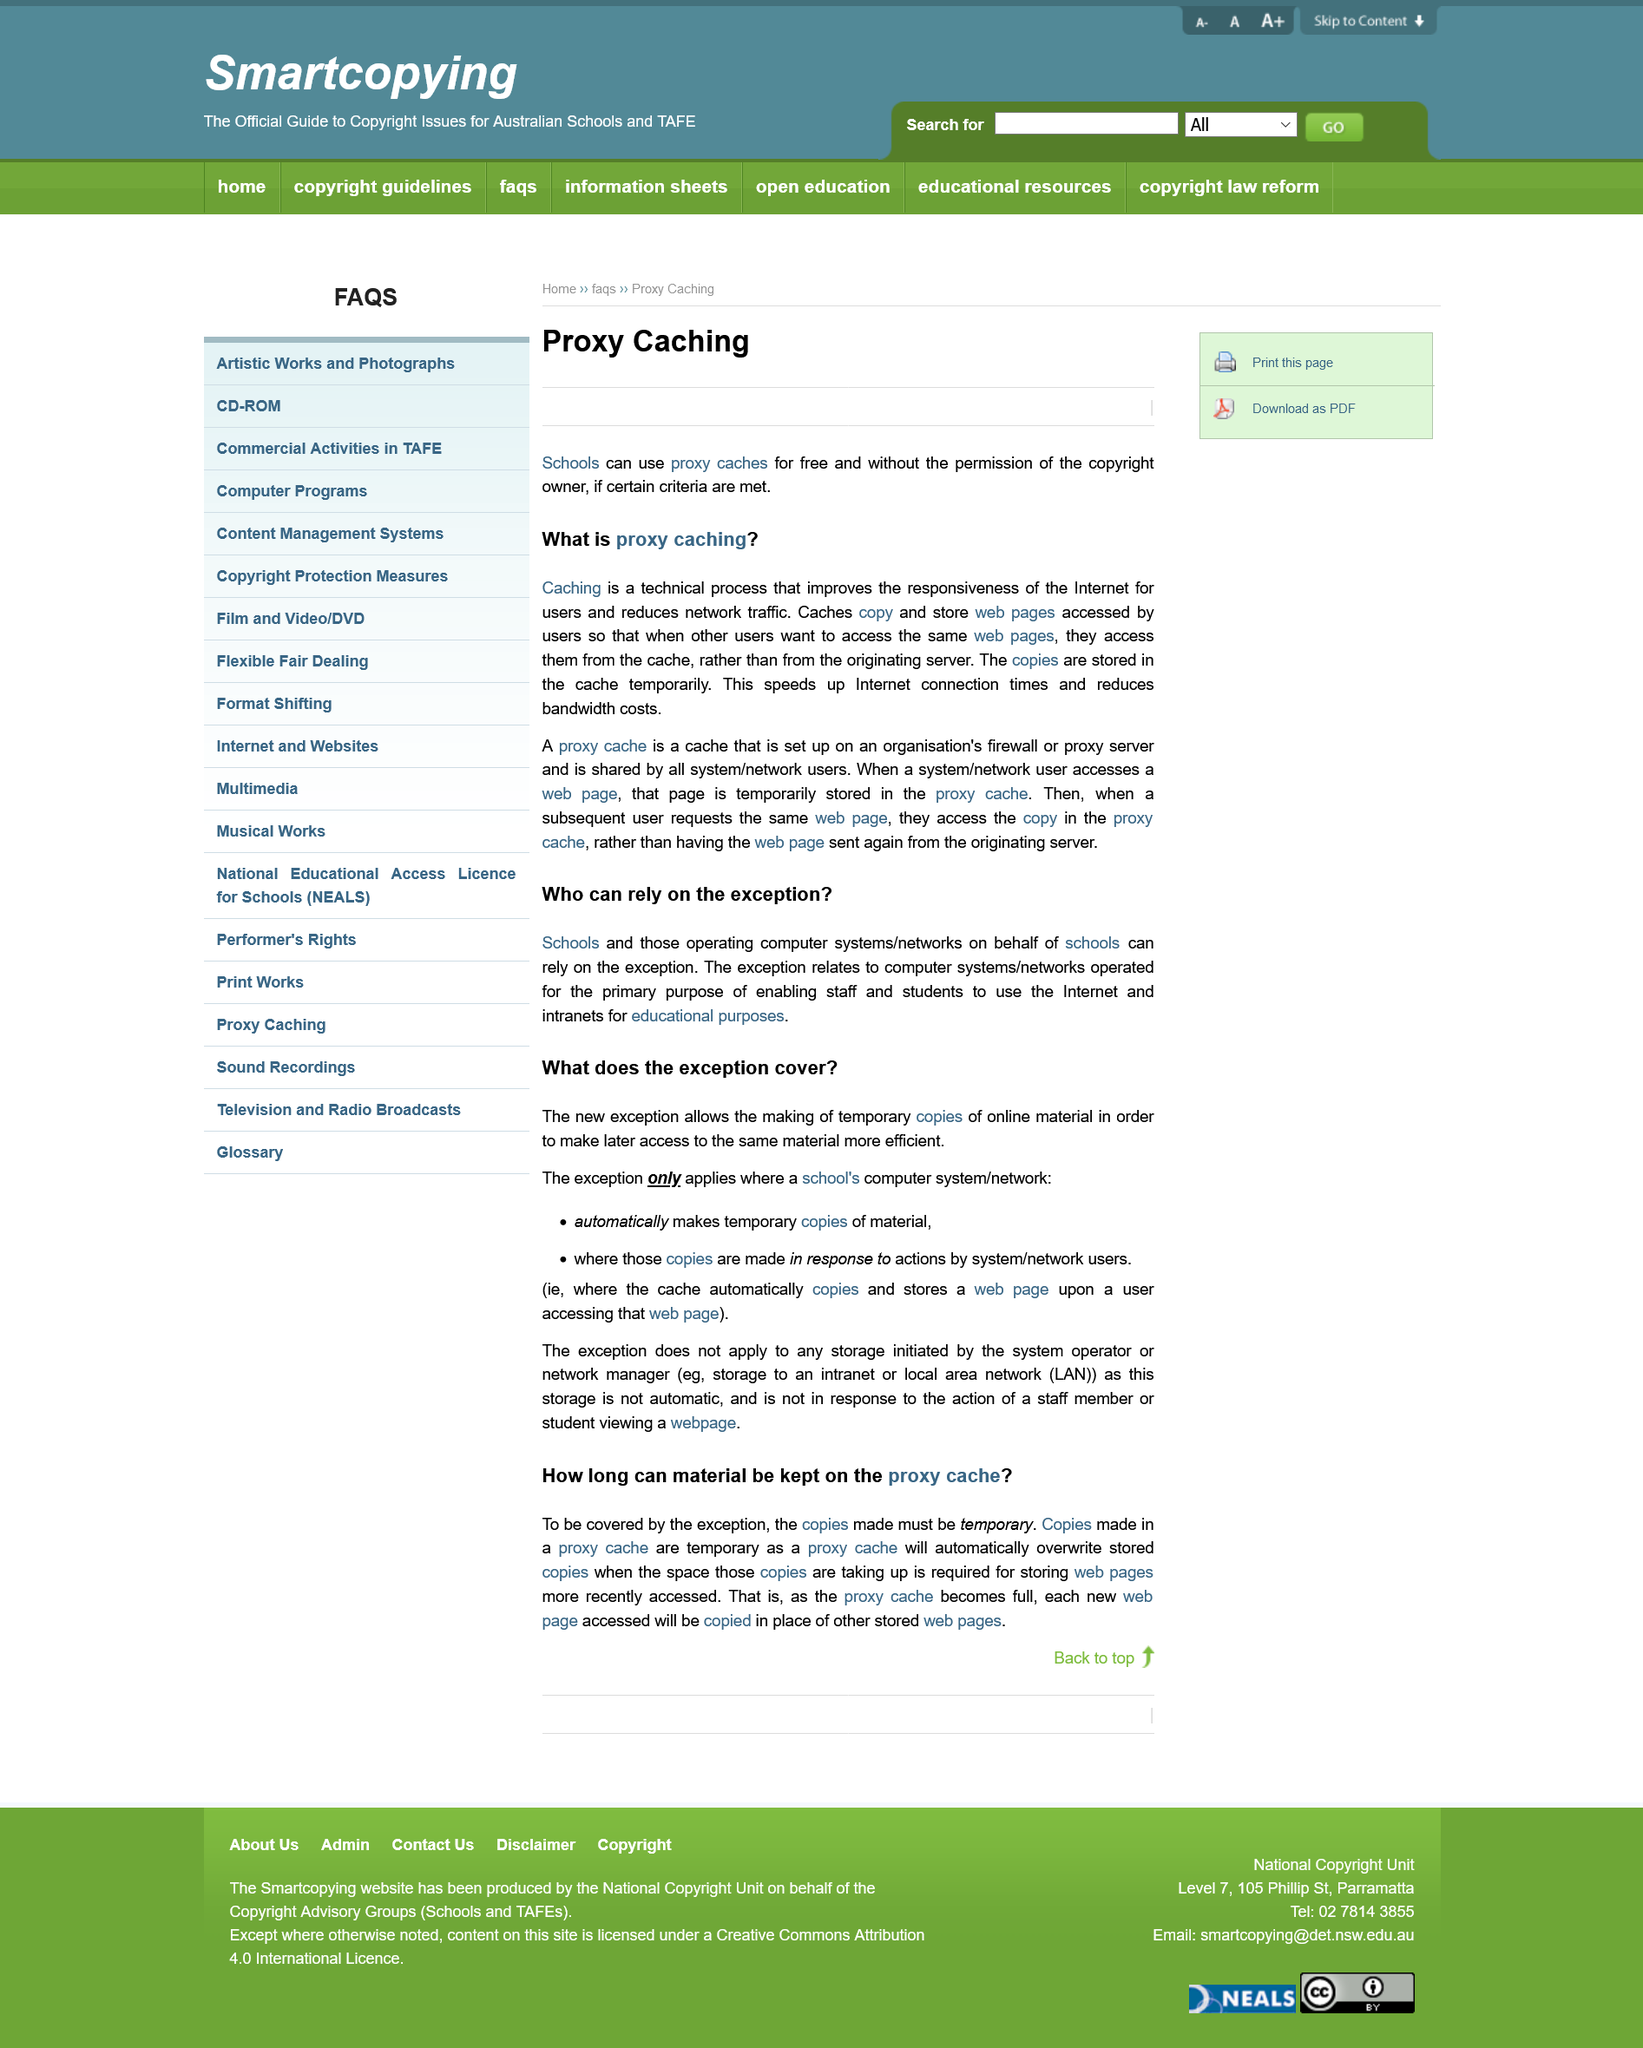Outline some significant characteristics in this image. Caching is a technical process used to improve the internet's responsiveness for users and reduce network traffic by temporarily storing frequently accessed data and content. Caching can potentially speed up the time it takes to access internet content. Schools can use proxy caches. 